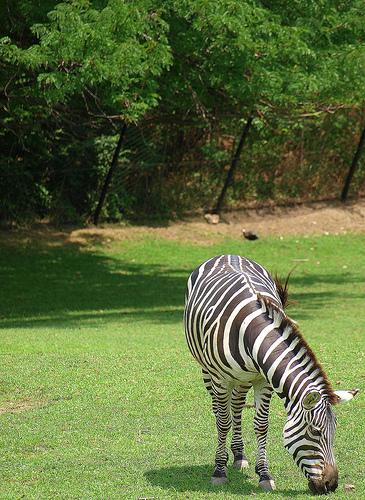Elaborate on the appearance and behavior of the main creature within the image. The zebra, which is black and white in color, has its head down as it eats grass, with two ears and a striped mane topped with black hair. Describe the setting and actions of the focal point of the image. Within a fenced pen containing green grass, dirt, and rocks, the zebra is grazing while surrounded by trees casting shade. Explain the scene in the photograph, including details about the zebra and its surroundings. On a sunny day, a black and white zebra grazes on green grass within a fenced enclosure, with trees growing behind the fence and casting shade. Explain the main focus of the image and any striking characteristics of its setting. The image focuses on a zebra with distinct black and white stripes, grazing on grass within a fenced enclosure lined with trees and casting shadows. Give a succinct description of the principal element in the image and its immediate context. A black and white zebra is busy grazing on grass within an enclosure surrounded by a chain link fence and nearby trees. Point out the primary object of the image and mention any notable physical aspects of its environment. The zebra, exhibiting black and white stripes, is the central focus, as it feeds on grass within a pen surrounded by a metal fence and trees. Provide a brief description of the central animal in the image and its activity. A zebra with black and white stripes is grazing on green grass in its enclosure. Write a brief summary of the dominant features of the image, including the subject and its surroundings. A zebra with black and white stripes grazes on grass inside a fenced pen, featuring patches of dirt, rocks, and trees providing shade. Detail the image's main subject's actions and the environment it is in. The zebra, grazing on green grass, is enclosed within a fenced area, with rocks and dirt in its pen, and leaning trees with green leaves overhead. In one sentence, describe the primary action involving the central figure of the image. A zebra, adorned with black and white stripes, is seen grazing on grass. 